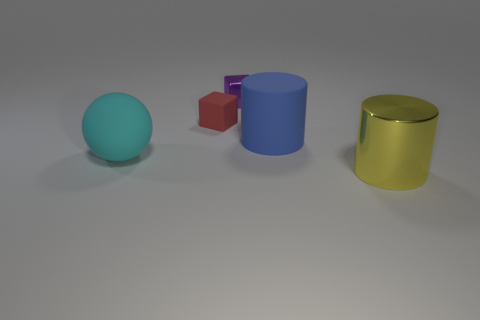Is the number of large things behind the rubber sphere greater than the number of tiny blue matte spheres?
Offer a terse response. Yes. What size is the yellow cylinder that is made of the same material as the purple cube?
Offer a terse response. Large. Are there any tiny red objects behind the large blue object?
Offer a terse response. Yes. Is the shape of the yellow thing the same as the red object?
Give a very brief answer. No. How big is the metal thing that is on the right side of the metal object that is behind the metallic thing right of the small purple block?
Offer a terse response. Large. What is the material of the large yellow object?
Give a very brief answer. Metal. There is a tiny metal object; does it have the same shape as the tiny matte object that is left of the big metal cylinder?
Give a very brief answer. Yes. There is a big object left of the large thing behind the big matte thing on the left side of the tiny purple thing; what is it made of?
Make the answer very short. Rubber. What number of metallic objects are there?
Ensure brevity in your answer.  2. How many blue objects are either rubber objects or big rubber cylinders?
Ensure brevity in your answer.  1. 